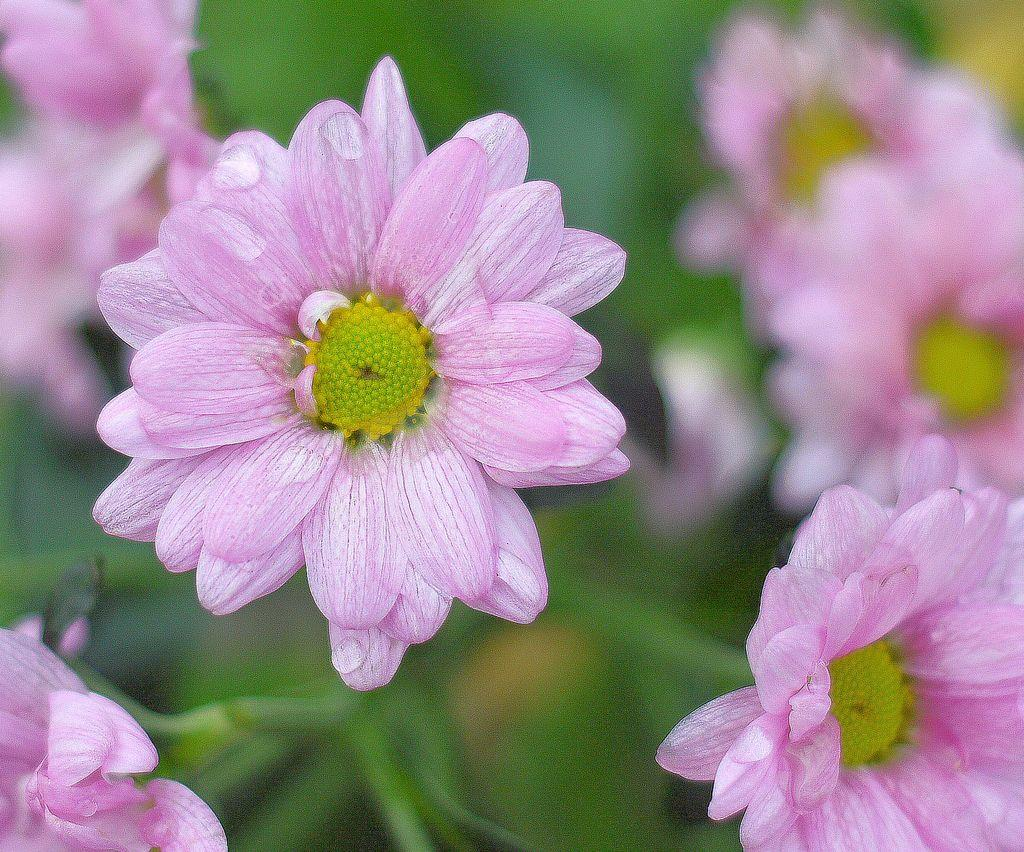What type of flowers are present in the image? There are pink flowers in the image. Can you describe the background of the image? The background of the image is blurred. Where is the mailbox located in the image? There is no mailbox present in the image. What type of paste is being used to stick the sheet to the wall in the image? There is no sheet or paste present in the image. 